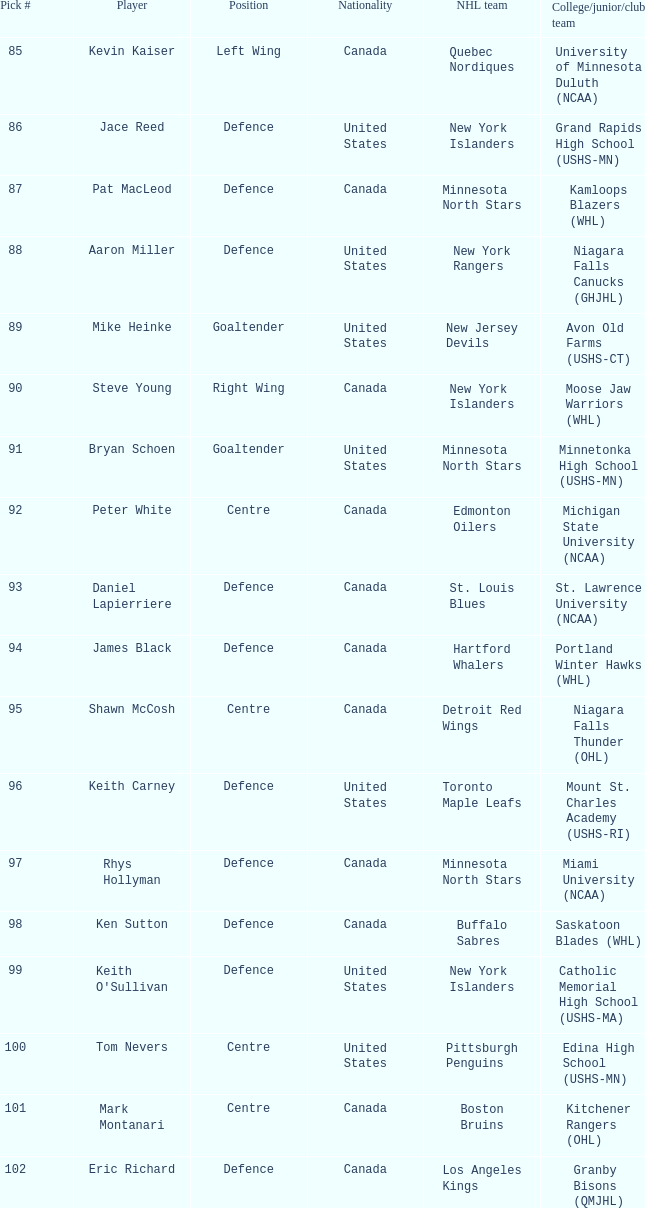What nationality is keith carney? United States. 